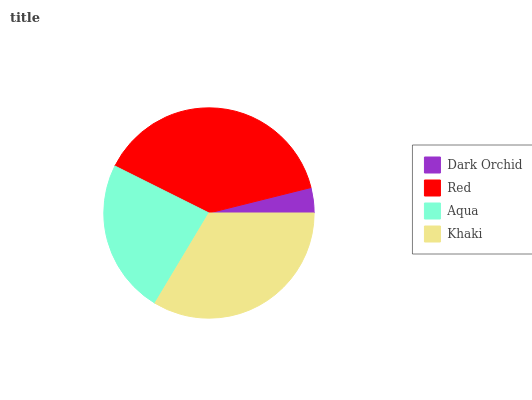Is Dark Orchid the minimum?
Answer yes or no. Yes. Is Red the maximum?
Answer yes or no. Yes. Is Aqua the minimum?
Answer yes or no. No. Is Aqua the maximum?
Answer yes or no. No. Is Red greater than Aqua?
Answer yes or no. Yes. Is Aqua less than Red?
Answer yes or no. Yes. Is Aqua greater than Red?
Answer yes or no. No. Is Red less than Aqua?
Answer yes or no. No. Is Khaki the high median?
Answer yes or no. Yes. Is Aqua the low median?
Answer yes or no. Yes. Is Aqua the high median?
Answer yes or no. No. Is Khaki the low median?
Answer yes or no. No. 